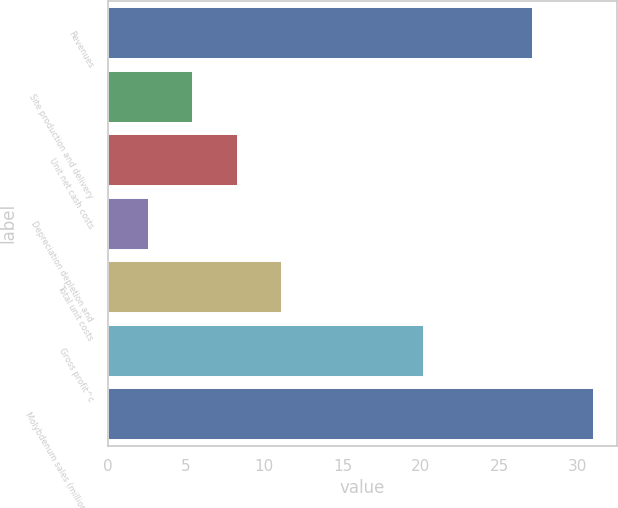<chart> <loc_0><loc_0><loc_500><loc_500><bar_chart><fcel>Revenues<fcel>Site production and delivery<fcel>Unit net cash costs<fcel>Depreciation depletion and<fcel>Total unit costs<fcel>Gross profit^c<fcel>Molybdenum sales (millions of<nl><fcel>27.12<fcel>5.39<fcel>8.23<fcel>2.55<fcel>11.08<fcel>20.15<fcel>31<nl></chart> 